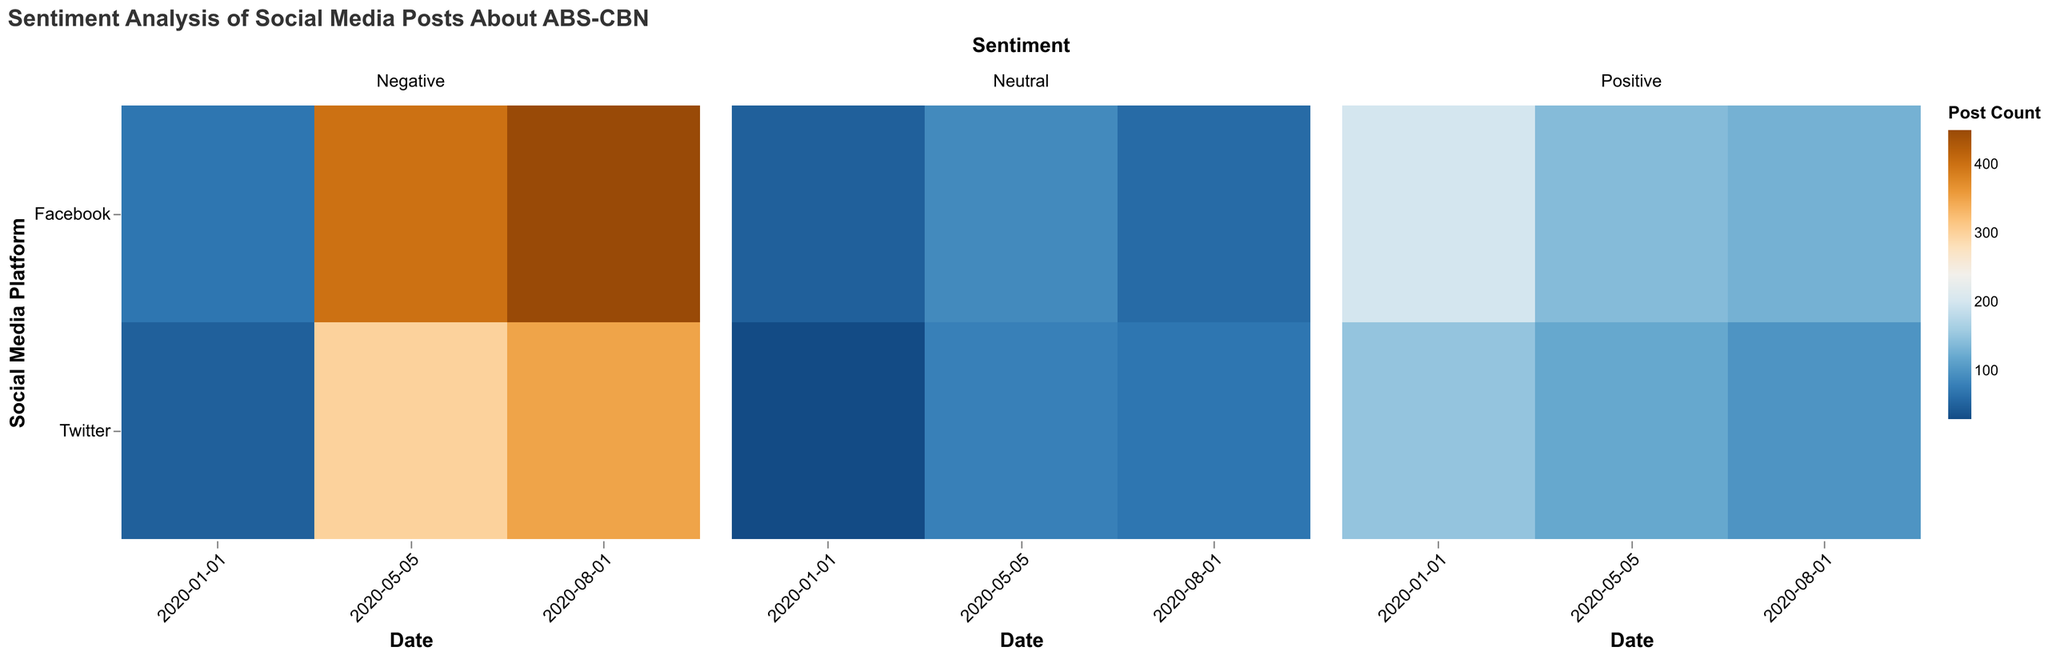What's the title of the heatmap? The title usually appears at the top of the figure and is mentioned in the 'title' field of the code.
Answer: Sentiment Analysis of Social Media Posts About ABS-CBN How many social media platforms are represented in the heatmap? The y-axis represents the social media platforms, and you can count the unique entries listed there.
Answer: 2 Which social media platform had the highest number of negative posts on May 5, 2020? Look at the heatmap for the highest color intensity in the 'Negative' sentiment section for the date 2020-05-05 on the y-axis corresponding to platforms.
Answer: Facebook How did the number of positive posts on Twitter change from January 1, 2020, to May 5, 2020? Find the two points for the date 2020-01-01 and 2020-05-05 in the 'Positive' sentiment section and compare their color intensities to determine if it increased or decreased.
Answer: Decreased Which date had the most neutral posts on Facebook? Look for the highest color intensity in the 'Neutral' sentiment section on the y-axis for Facebook.
Answer: May 5, 2020 How many more negative posts were there on Facebook compared to Twitter on August 1, 2020? Find the counts for 'Negative' posts on Facebook and Twitter for the date 2020-08-01, then subtract the count of Twitter from Facebook.
Answer: 100 more What sentiment had the least number of posts across all dates for Twitter? Find the sentiment section for Twitter across all dates and identify the lightest color intensity.
Answer: Neutral Compare the trend in neutral posts between January 1, 2020, and August 1, 2020, on Facebook and Twitter. Are they increasing, decreasing, or stable? Observe the color intensities for the 'Neutral' sentiment section on January 1 and August 1 for both platforms and determine the trend.
Answer: Facebook: Decreasing, Twitter: Decreasing How many positive posts were there on Facebook on January 1, 2020? Check the color intensity for Facebook in the 'Positive' sentiment section on the date January 1, 2020, and match it to the count.
Answer: 200 What's the difference between the number of positive and neutral posts on Twitter on May 5, 2020? Find the counts for 'Positive' and 'Neutral' posts on Twitter on the date 2020-05-05 and subtract the smaller count from the larger count.
Answer: 40 